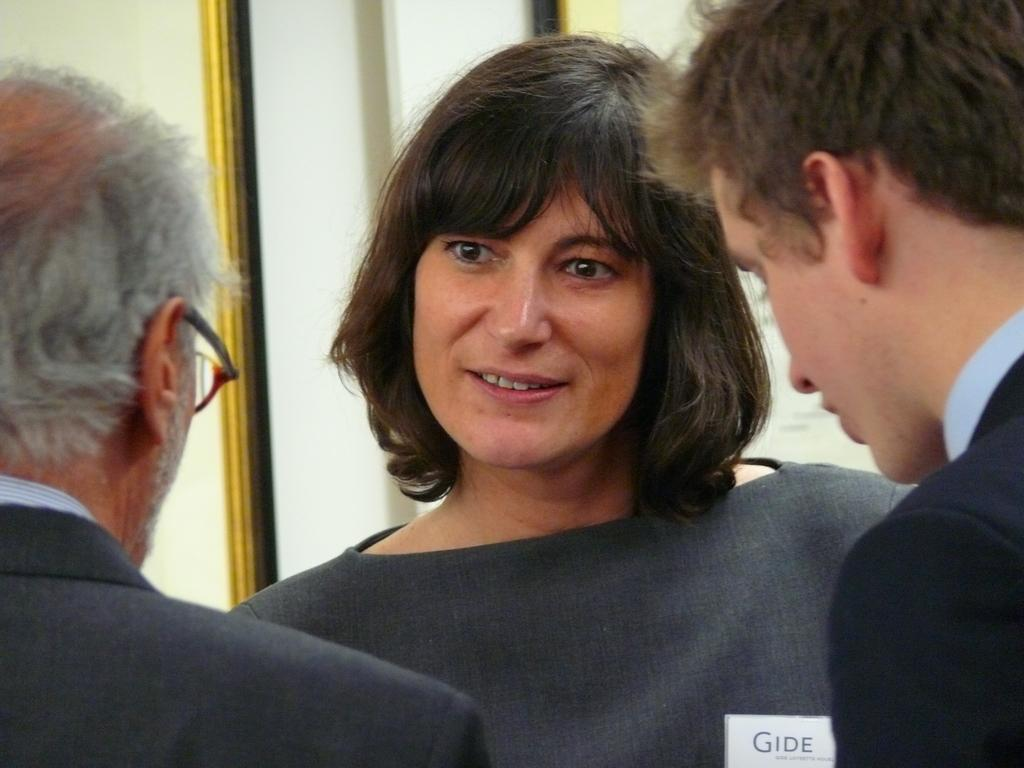How many people are in the image? There are three persons in the image. Can you describe the expression of one of the persons? A woman is smiling in the image. What can be seen in the background of the image? There is a wall in the background of the image. What type of pain is the woman experiencing in the image? There is no indication in the image that the woman is experiencing any pain. 